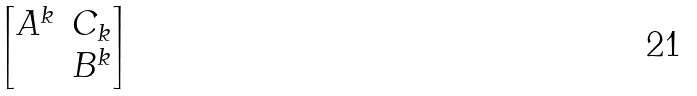<formula> <loc_0><loc_0><loc_500><loc_500>\begin{bmatrix} A ^ { k } & C _ { k } \\ & B ^ { k } \end{bmatrix}</formula> 